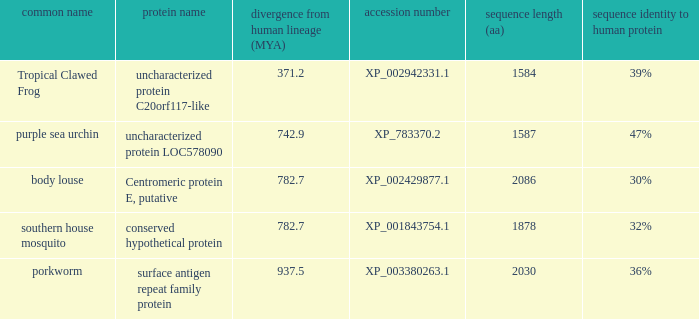9? None. 